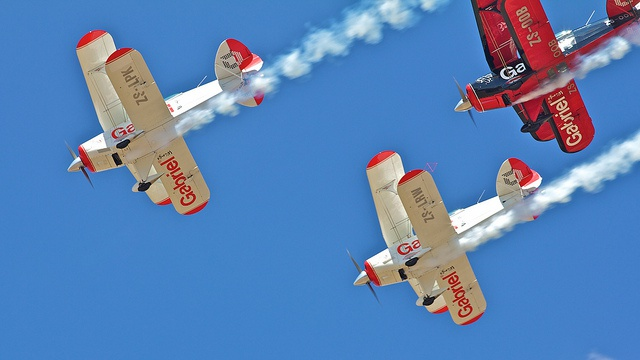Describe the objects in this image and their specific colors. I can see airplane in gray, tan, darkgray, white, and brown tones, airplane in gray, brown, black, and maroon tones, and airplane in gray, tan, darkgray, white, and brown tones in this image. 